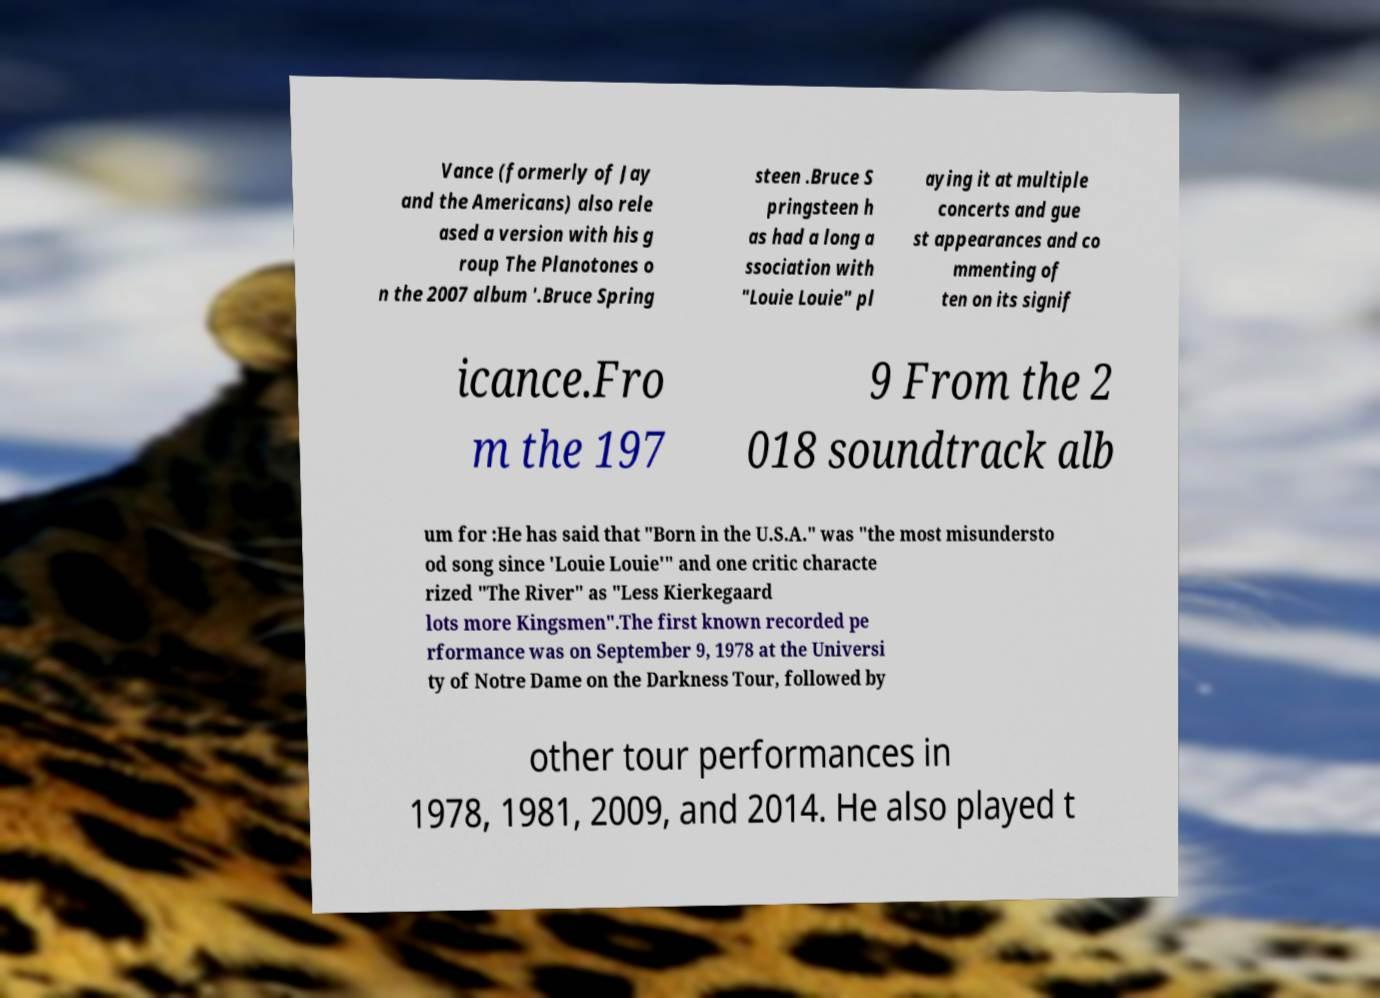Could you extract and type out the text from this image? Vance (formerly of Jay and the Americans) also rele ased a version with his g roup The Planotones o n the 2007 album '.Bruce Spring steen .Bruce S pringsteen h as had a long a ssociation with "Louie Louie" pl aying it at multiple concerts and gue st appearances and co mmenting of ten on its signif icance.Fro m the 197 9 From the 2 018 soundtrack alb um for :He has said that "Born in the U.S.A." was "the most misundersto od song since 'Louie Louie'" and one critic characte rized "The River" as "Less Kierkegaard lots more Kingsmen".The first known recorded pe rformance was on September 9, 1978 at the Universi ty of Notre Dame on the Darkness Tour, followed by other tour performances in 1978, 1981, 2009, and 2014. He also played t 